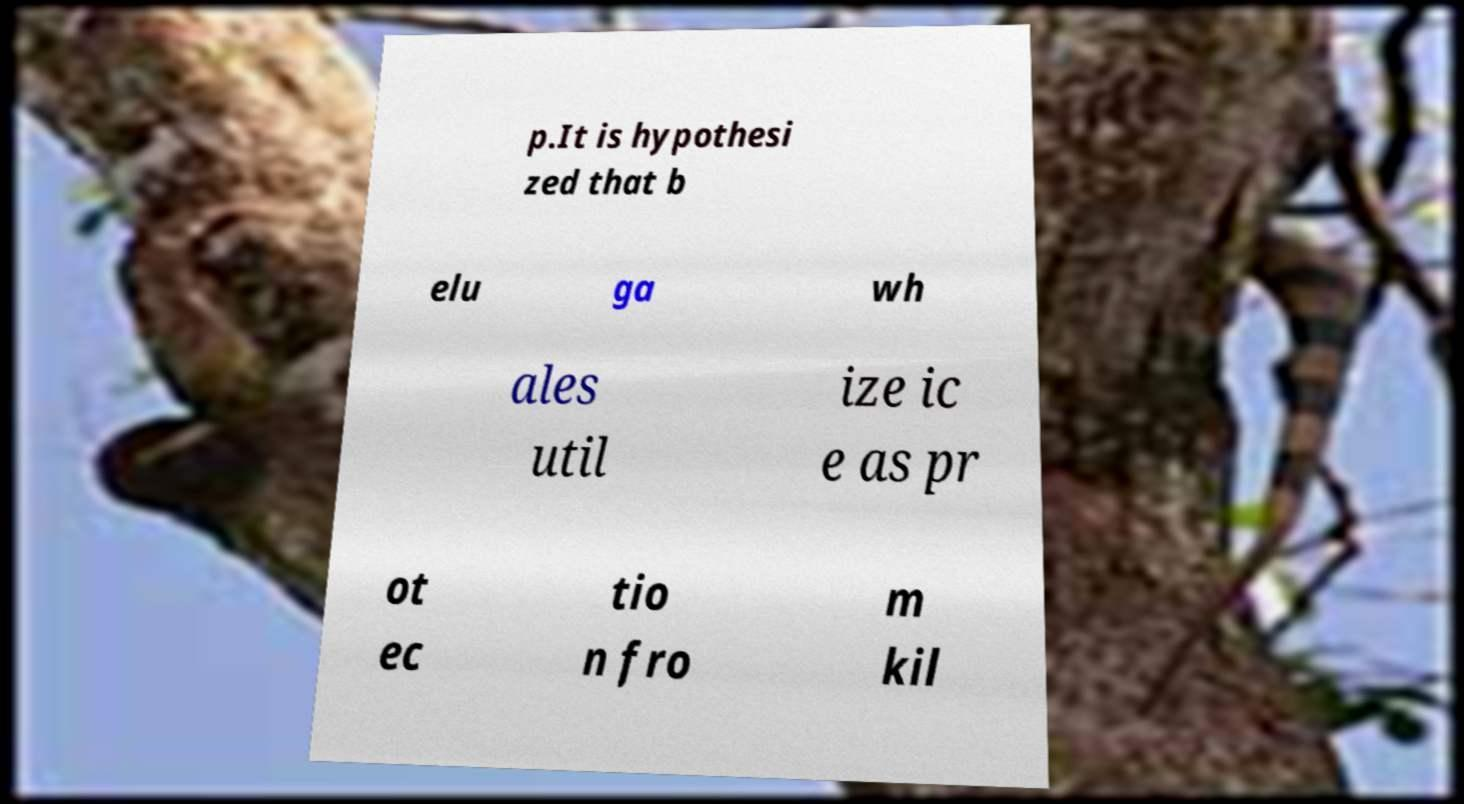There's text embedded in this image that I need extracted. Can you transcribe it verbatim? p.It is hypothesi zed that b elu ga wh ales util ize ic e as pr ot ec tio n fro m kil 